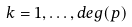Convert formula to latex. <formula><loc_0><loc_0><loc_500><loc_500>k = 1 , \dots , d e g ( p )</formula> 